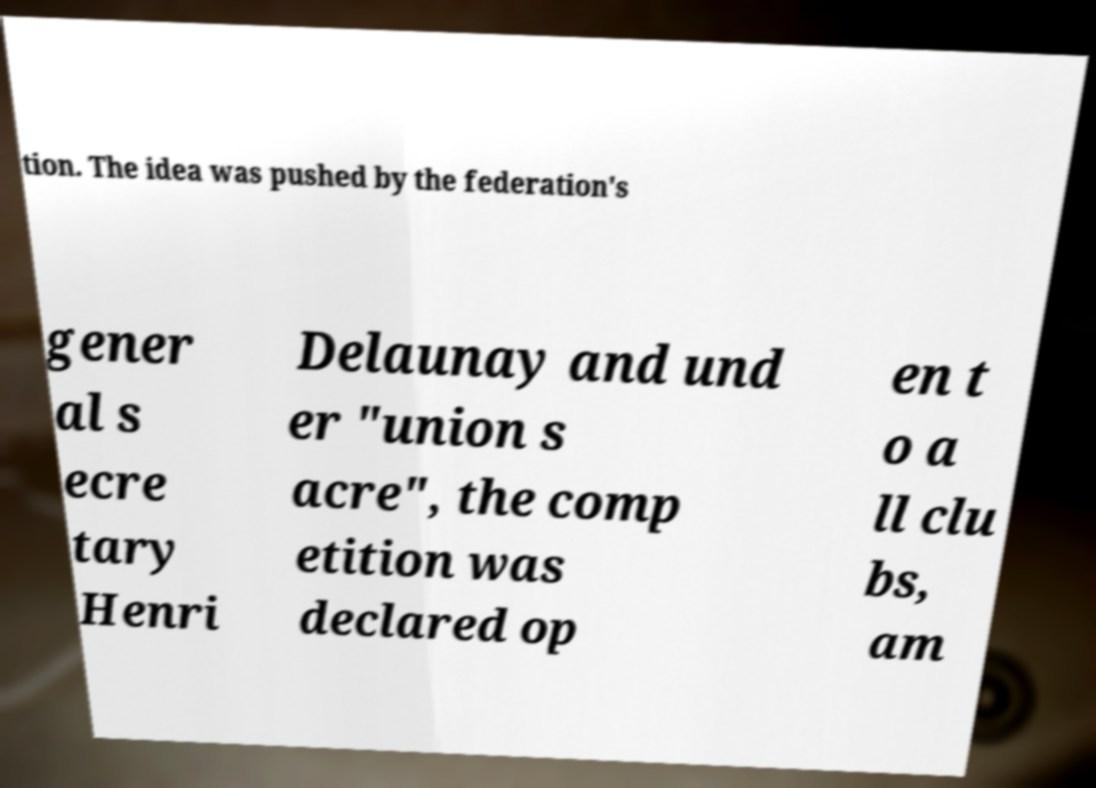Please identify and transcribe the text found in this image. tion. The idea was pushed by the federation's gener al s ecre tary Henri Delaunay and und er "union s acre", the comp etition was declared op en t o a ll clu bs, am 